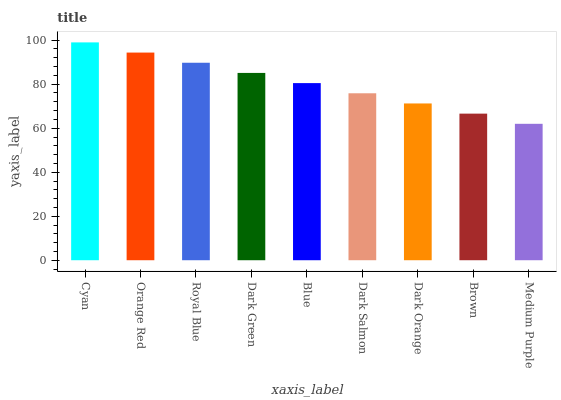Is Medium Purple the minimum?
Answer yes or no. Yes. Is Cyan the maximum?
Answer yes or no. Yes. Is Orange Red the minimum?
Answer yes or no. No. Is Orange Red the maximum?
Answer yes or no. No. Is Cyan greater than Orange Red?
Answer yes or no. Yes. Is Orange Red less than Cyan?
Answer yes or no. Yes. Is Orange Red greater than Cyan?
Answer yes or no. No. Is Cyan less than Orange Red?
Answer yes or no. No. Is Blue the high median?
Answer yes or no. Yes. Is Blue the low median?
Answer yes or no. Yes. Is Royal Blue the high median?
Answer yes or no. No. Is Dark Green the low median?
Answer yes or no. No. 